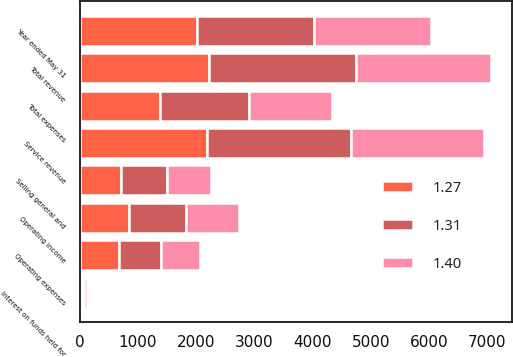Convert chart to OTSL. <chart><loc_0><loc_0><loc_500><loc_500><stacked_bar_chart><ecel><fcel>Year ended May 31<fcel>Service revenue<fcel>Interest on funds held for<fcel>Total revenue<fcel>Operating expenses<fcel>Selling general and<fcel>Total expenses<fcel>Operating income<nl><fcel>1.31<fcel>2014<fcel>2478.2<fcel>40.7<fcel>2518.9<fcel>732.5<fcel>803.7<fcel>1536.2<fcel>982.7<nl><fcel>1.4<fcel>2013<fcel>2285.2<fcel>41<fcel>2326.2<fcel>671.3<fcel>750.1<fcel>1421.4<fcel>904.8<nl><fcel>1.27<fcel>2012<fcel>2186.2<fcel>43.6<fcel>2229.8<fcel>670.1<fcel>705.8<fcel>1375.9<fcel>853.9<nl></chart> 